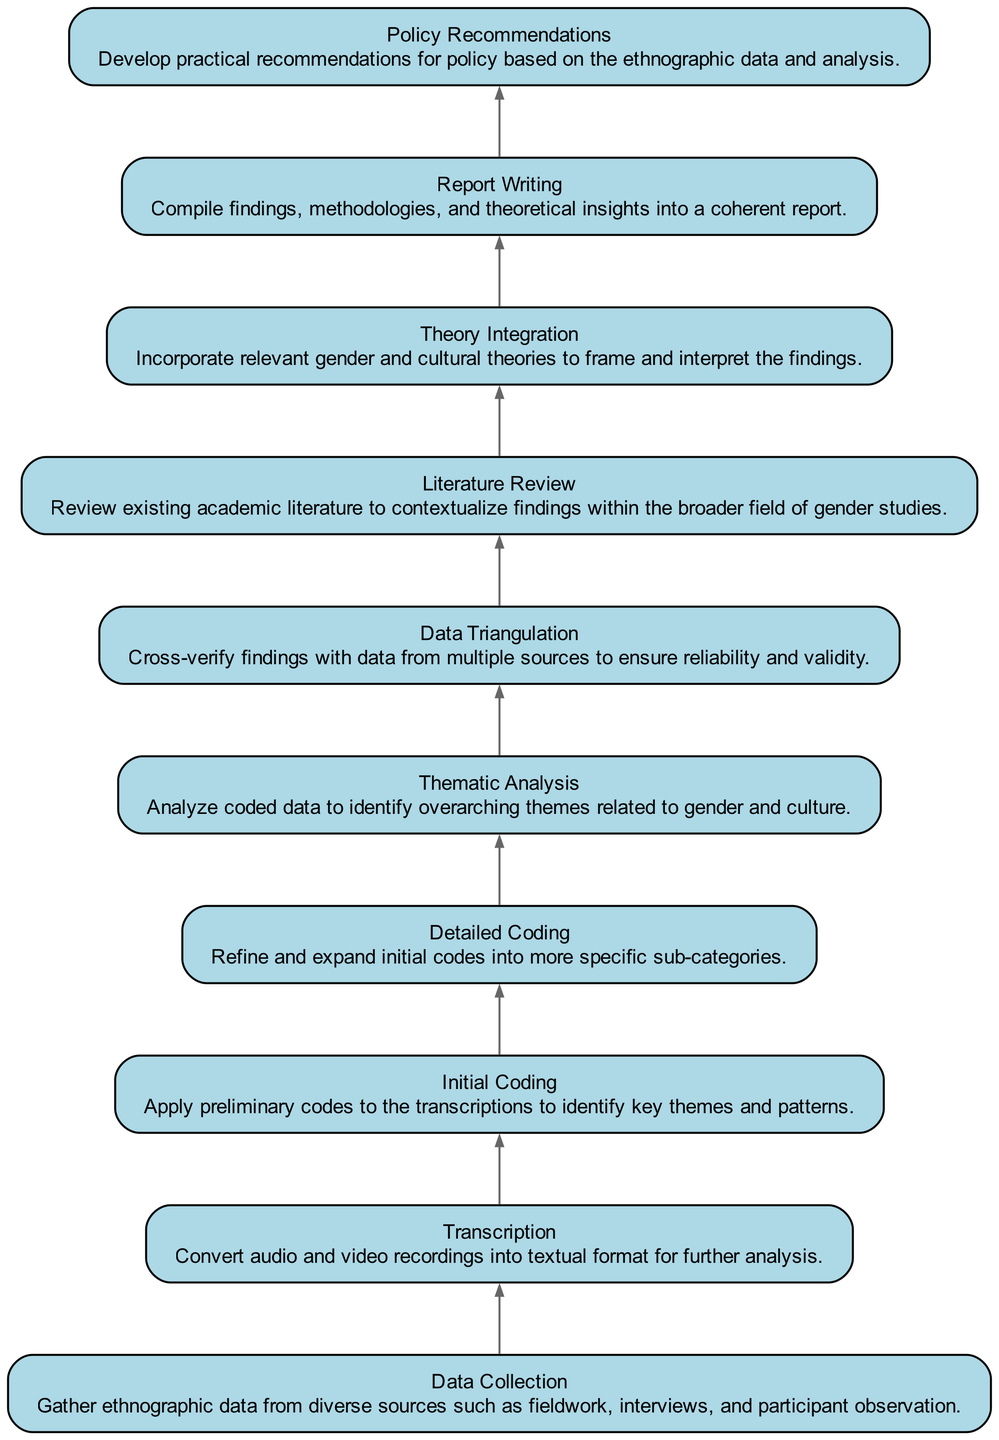What is the first step in the process? The first step listed at the bottom of the flow chart is "Data Collection." In a bottom-to-up flow, this is the initial action before any other steps are taken.
Answer: Data Collection How many total steps are included in the process? By counting each element in the diagram from bottom to top, there are a total of ten distinct steps listed in the flow.
Answer: Ten What follows after "Transcription" in the flow? The step that comes directly after "Transcription" is "Initial Coding." Moving sequentially up the flow chart shows this direct connection.
Answer: Initial Coding What is the last step in the process? The final step at the top of the flow chart is "Policy Recommendations," indicating the end point where practical implications are drawn from the study.
Answer: Policy Recommendations Which step includes verifying findings? The step that involves verifying findings is "Data Triangulation." This step is focused on ensuring that the results are credible by checking against multiple sources.
Answer: Data Triangulation What is the relationship between "Detailed Coding" and "Thematic Analysis"? "Detailed Coding" is a step that precedes "Thematic Analysis" in the flow. This means that before thematic analysis can take place, detailed coding must be completed to refine categories.
Answer: Precedes Which step provides context to findings? The step that provides context to findings is "Literature Review." This step involves examining existing literature for background that aids in understanding the research results.
Answer: Literature Review What does "Theory Integration" add to the findings? "Theory Integration" incorporates relevant theories into the analysis, allowing for a better framing and interpretation of the data gathered during the research.
Answer: Theoretical context How does the flow diagram illustrate the integration of data? The flow diagram visually links each step in a sequential order, illustrating how each component builds on the previous one, fostering an understanding of the integration process.
Answer: Sequential process 